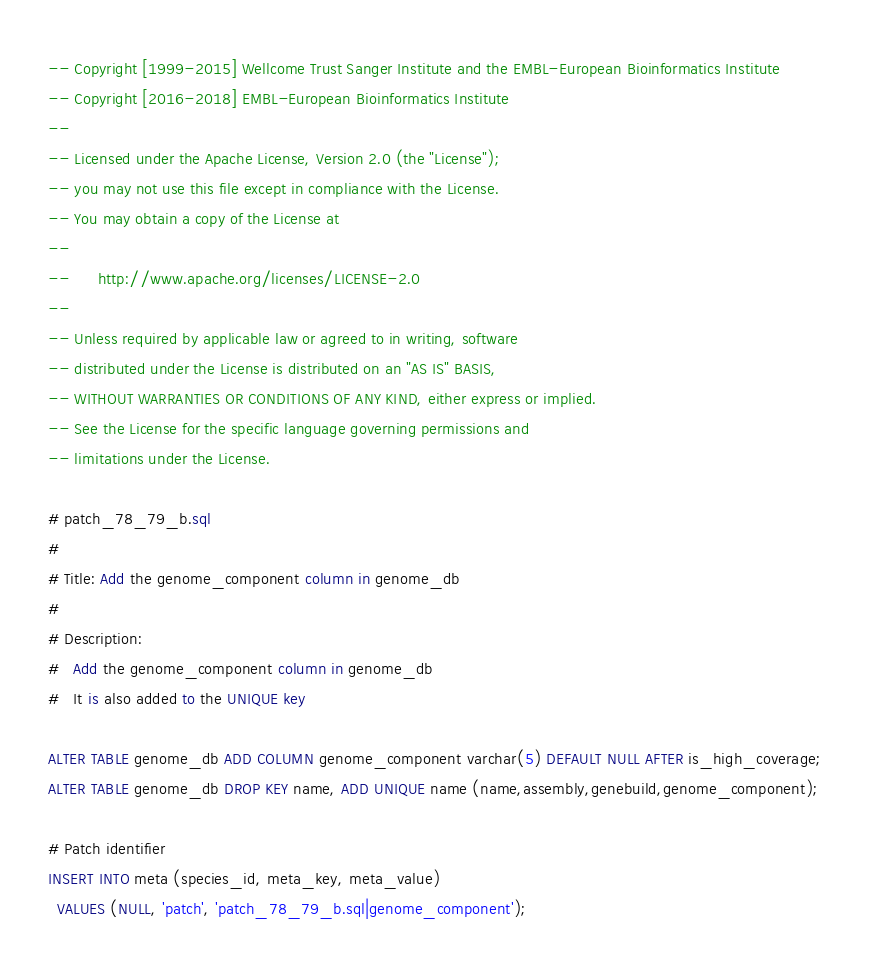Convert code to text. <code><loc_0><loc_0><loc_500><loc_500><_SQL_>-- Copyright [1999-2015] Wellcome Trust Sanger Institute and the EMBL-European Bioinformatics Institute
-- Copyright [2016-2018] EMBL-European Bioinformatics Institute
-- 
-- Licensed under the Apache License, Version 2.0 (the "License");
-- you may not use this file except in compliance with the License.
-- You may obtain a copy of the License at
-- 
--      http://www.apache.org/licenses/LICENSE-2.0
-- 
-- Unless required by applicable law or agreed to in writing, software
-- distributed under the License is distributed on an "AS IS" BASIS,
-- WITHOUT WARRANTIES OR CONDITIONS OF ANY KIND, either express or implied.
-- See the License for the specific language governing permissions and
-- limitations under the License.

# patch_78_79_b.sql
#
# Title: Add the genome_component column in genome_db
#
# Description:
#   Add the genome_component column in genome_db
#   It is also added to the UNIQUE key

ALTER TABLE genome_db ADD COLUMN genome_component varchar(5) DEFAULT NULL AFTER is_high_coverage;
ALTER TABLE genome_db DROP KEY name, ADD UNIQUE name (name,assembly,genebuild,genome_component);

# Patch identifier
INSERT INTO meta (species_id, meta_key, meta_value)
  VALUES (NULL, 'patch', 'patch_78_79_b.sql|genome_component');
</code> 